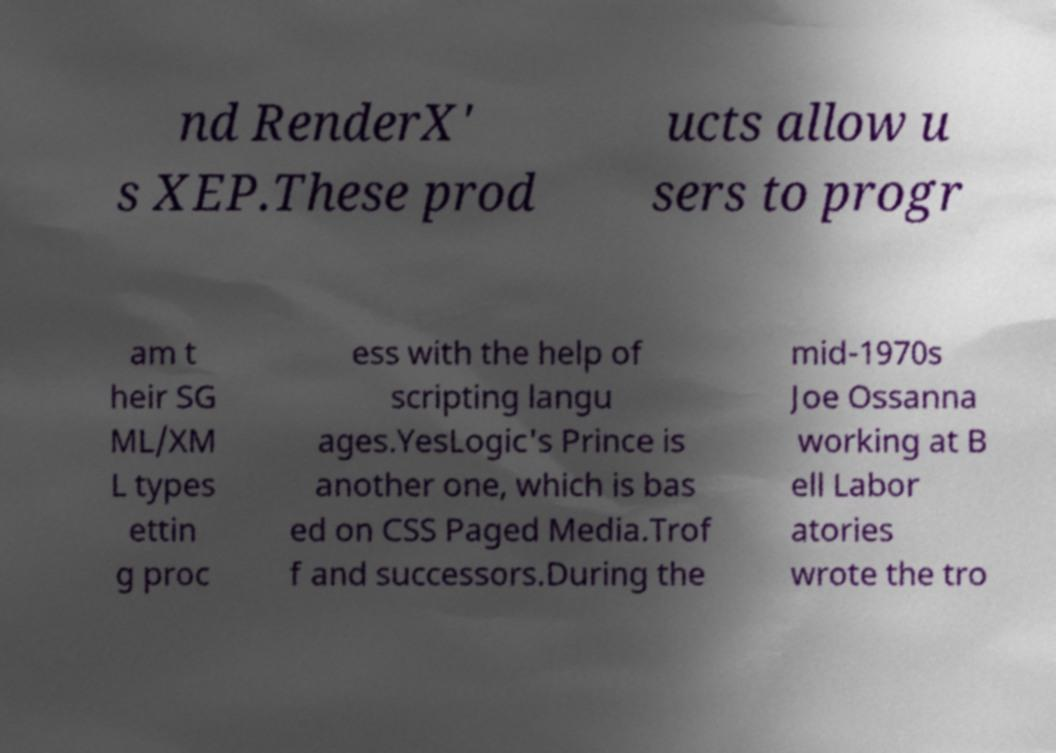I need the written content from this picture converted into text. Can you do that? nd RenderX' s XEP.These prod ucts allow u sers to progr am t heir SG ML/XM L types ettin g proc ess with the help of scripting langu ages.YesLogic's Prince is another one, which is bas ed on CSS Paged Media.Trof f and successors.During the mid-1970s Joe Ossanna working at B ell Labor atories wrote the tro 